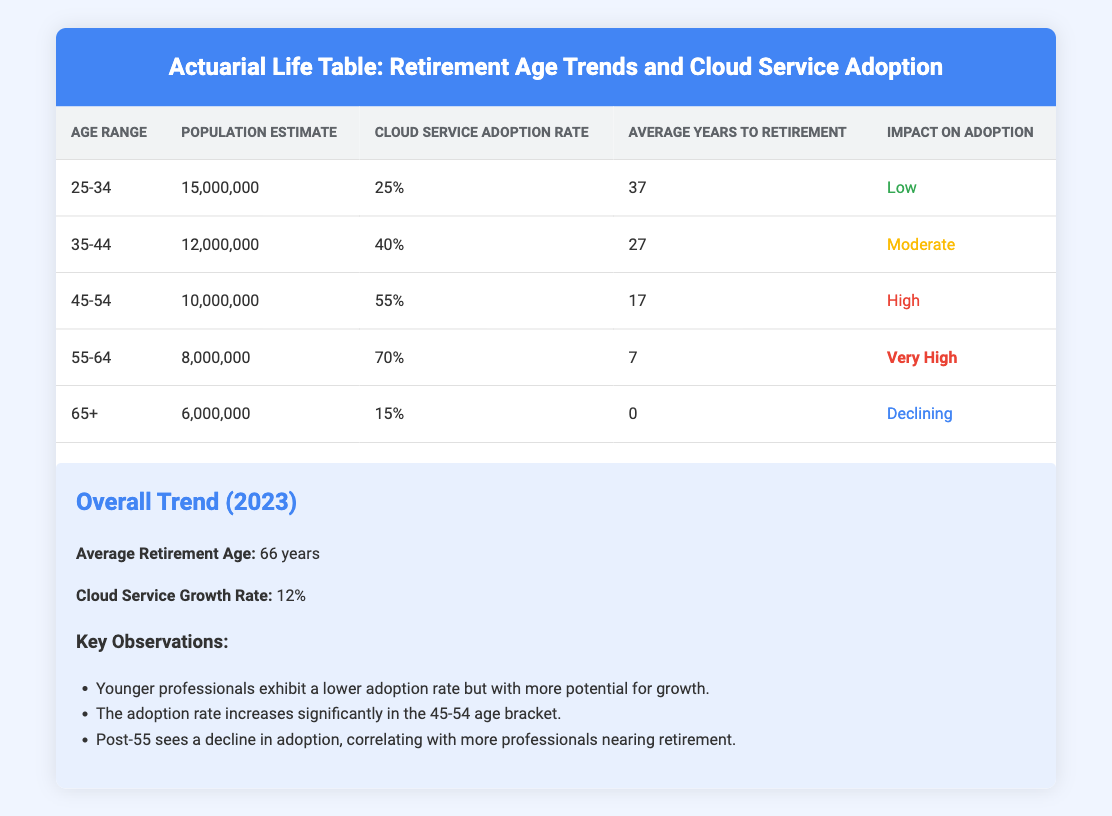What is the cloud service adoption rate for the age group 45-54? The table directly lists the cloud service adoption rate for each age range. For the age group 45-54, it states that the cloud service adoption rate is 55%.
Answer: 55% Which age group has the highest population estimate? By reviewing the "Population Estimate" column, the highest value is 15,000,000 associated with the age group 25-34.
Answer: 25-34 What is the average years to retirement for the age group 55-64? The table lists the average years to retirement for each age group. For the 55-64 age range, it indicates that there are 7 years to retirement.
Answer: 7 True or False: The cloud service adoption rate decreases as the age group increases after 45 years. Reviewing the adoption rates, the age groups show that for 45-54 it is 55%, and for 55-64 it is 70%, indicating an increase; however, it then drops to 15% for 65+, showing a decline after age 54. Therefore, the statement is true.
Answer: True What is the combined population estimate for age groups 25-34 and 35-44? The population estimates for these two age groups are 15,000,000 and 12,000,000, respectively. By adding these together (15,000,000 + 12,000,000), the total is 27,000,000.
Answer: 27,000,000 What is the average cloud service adoption rate for all age groups? To find the average adoption rate, we sum all the individual rates (0.25 + 0.40 + 0.55 + 0.70 + 0.15) which equals 2.15. Dividing by the number of age groups (5) results in an average adoption rate of 0.43.
Answer: 0.43 Which age group experiences a very high impact on cloud service adoption? The "Impact on Adoption" column indicates that the age group 55-64 has a "Very High" impact on adoption, as per the table.
Answer: 55-64 Determine the age group with the lowest cloud service adoption rate. By reviewing the cloud service adoption rates listed for each age range, it is evident that the group 65+ has the lowest adoption rate at 15%.
Answer: 65+ 